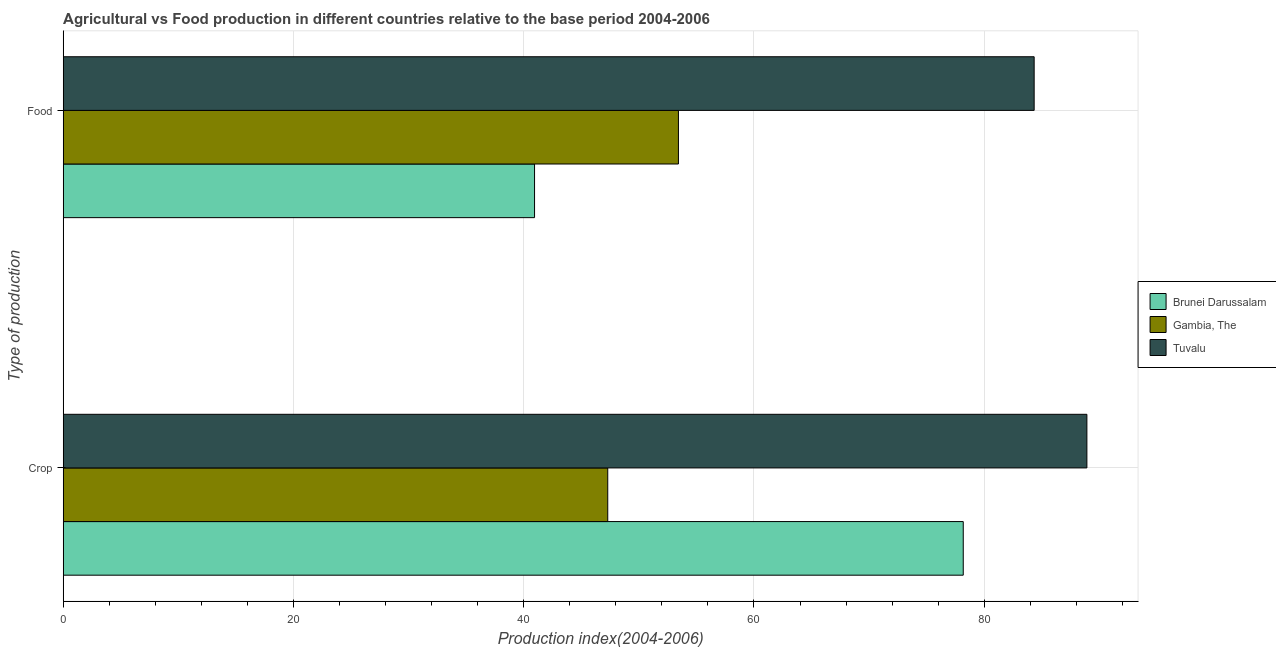How many groups of bars are there?
Offer a terse response. 2. How many bars are there on the 2nd tick from the bottom?
Provide a short and direct response. 3. What is the label of the 1st group of bars from the top?
Offer a very short reply. Food. What is the food production index in Brunei Darussalam?
Make the answer very short. 40.94. Across all countries, what is the maximum food production index?
Provide a short and direct response. 84.34. Across all countries, what is the minimum food production index?
Your answer should be very brief. 40.94. In which country was the food production index maximum?
Your response must be concise. Tuvalu. In which country was the crop production index minimum?
Make the answer very short. Gambia, The. What is the total food production index in the graph?
Offer a terse response. 178.72. What is the difference between the crop production index in Gambia, The and that in Tuvalu?
Give a very brief answer. -41.62. What is the difference between the crop production index in Brunei Darussalam and the food production index in Tuvalu?
Your answer should be compact. -6.16. What is the average crop production index per country?
Give a very brief answer. 71.47. What is the difference between the food production index and crop production index in Brunei Darussalam?
Your response must be concise. -37.24. What is the ratio of the crop production index in Gambia, The to that in Tuvalu?
Give a very brief answer. 0.53. In how many countries, is the food production index greater than the average food production index taken over all countries?
Your response must be concise. 1. What does the 1st bar from the top in Food represents?
Your response must be concise. Tuvalu. What does the 3rd bar from the bottom in Crop represents?
Offer a very short reply. Tuvalu. How many bars are there?
Offer a very short reply. 6. What is the difference between two consecutive major ticks on the X-axis?
Your response must be concise. 20. Does the graph contain any zero values?
Your response must be concise. No. Does the graph contain grids?
Keep it short and to the point. Yes. Where does the legend appear in the graph?
Your response must be concise. Center right. What is the title of the graph?
Your response must be concise. Agricultural vs Food production in different countries relative to the base period 2004-2006. What is the label or title of the X-axis?
Provide a succinct answer. Production index(2004-2006). What is the label or title of the Y-axis?
Provide a short and direct response. Type of production. What is the Production index(2004-2006) of Brunei Darussalam in Crop?
Provide a succinct answer. 78.18. What is the Production index(2004-2006) in Gambia, The in Crop?
Offer a terse response. 47.3. What is the Production index(2004-2006) in Tuvalu in Crop?
Ensure brevity in your answer.  88.92. What is the Production index(2004-2006) in Brunei Darussalam in Food?
Ensure brevity in your answer.  40.94. What is the Production index(2004-2006) in Gambia, The in Food?
Your response must be concise. 53.44. What is the Production index(2004-2006) in Tuvalu in Food?
Your response must be concise. 84.34. Across all Type of production, what is the maximum Production index(2004-2006) in Brunei Darussalam?
Give a very brief answer. 78.18. Across all Type of production, what is the maximum Production index(2004-2006) in Gambia, The?
Your response must be concise. 53.44. Across all Type of production, what is the maximum Production index(2004-2006) of Tuvalu?
Provide a short and direct response. 88.92. Across all Type of production, what is the minimum Production index(2004-2006) of Brunei Darussalam?
Keep it short and to the point. 40.94. Across all Type of production, what is the minimum Production index(2004-2006) in Gambia, The?
Make the answer very short. 47.3. Across all Type of production, what is the minimum Production index(2004-2006) in Tuvalu?
Your answer should be very brief. 84.34. What is the total Production index(2004-2006) in Brunei Darussalam in the graph?
Give a very brief answer. 119.12. What is the total Production index(2004-2006) of Gambia, The in the graph?
Offer a terse response. 100.74. What is the total Production index(2004-2006) in Tuvalu in the graph?
Make the answer very short. 173.26. What is the difference between the Production index(2004-2006) of Brunei Darussalam in Crop and that in Food?
Your answer should be compact. 37.24. What is the difference between the Production index(2004-2006) of Gambia, The in Crop and that in Food?
Give a very brief answer. -6.14. What is the difference between the Production index(2004-2006) of Tuvalu in Crop and that in Food?
Give a very brief answer. 4.58. What is the difference between the Production index(2004-2006) in Brunei Darussalam in Crop and the Production index(2004-2006) in Gambia, The in Food?
Offer a very short reply. 24.74. What is the difference between the Production index(2004-2006) of Brunei Darussalam in Crop and the Production index(2004-2006) of Tuvalu in Food?
Your response must be concise. -6.16. What is the difference between the Production index(2004-2006) in Gambia, The in Crop and the Production index(2004-2006) in Tuvalu in Food?
Your answer should be very brief. -37.04. What is the average Production index(2004-2006) of Brunei Darussalam per Type of production?
Provide a succinct answer. 59.56. What is the average Production index(2004-2006) of Gambia, The per Type of production?
Your answer should be very brief. 50.37. What is the average Production index(2004-2006) in Tuvalu per Type of production?
Keep it short and to the point. 86.63. What is the difference between the Production index(2004-2006) of Brunei Darussalam and Production index(2004-2006) of Gambia, The in Crop?
Your answer should be very brief. 30.88. What is the difference between the Production index(2004-2006) of Brunei Darussalam and Production index(2004-2006) of Tuvalu in Crop?
Your answer should be very brief. -10.74. What is the difference between the Production index(2004-2006) of Gambia, The and Production index(2004-2006) of Tuvalu in Crop?
Your answer should be very brief. -41.62. What is the difference between the Production index(2004-2006) in Brunei Darussalam and Production index(2004-2006) in Tuvalu in Food?
Your response must be concise. -43.4. What is the difference between the Production index(2004-2006) of Gambia, The and Production index(2004-2006) of Tuvalu in Food?
Keep it short and to the point. -30.9. What is the ratio of the Production index(2004-2006) in Brunei Darussalam in Crop to that in Food?
Your answer should be very brief. 1.91. What is the ratio of the Production index(2004-2006) in Gambia, The in Crop to that in Food?
Provide a succinct answer. 0.89. What is the ratio of the Production index(2004-2006) of Tuvalu in Crop to that in Food?
Keep it short and to the point. 1.05. What is the difference between the highest and the second highest Production index(2004-2006) in Brunei Darussalam?
Your answer should be very brief. 37.24. What is the difference between the highest and the second highest Production index(2004-2006) of Gambia, The?
Keep it short and to the point. 6.14. What is the difference between the highest and the second highest Production index(2004-2006) of Tuvalu?
Ensure brevity in your answer.  4.58. What is the difference between the highest and the lowest Production index(2004-2006) in Brunei Darussalam?
Ensure brevity in your answer.  37.24. What is the difference between the highest and the lowest Production index(2004-2006) of Gambia, The?
Offer a terse response. 6.14. What is the difference between the highest and the lowest Production index(2004-2006) of Tuvalu?
Offer a terse response. 4.58. 